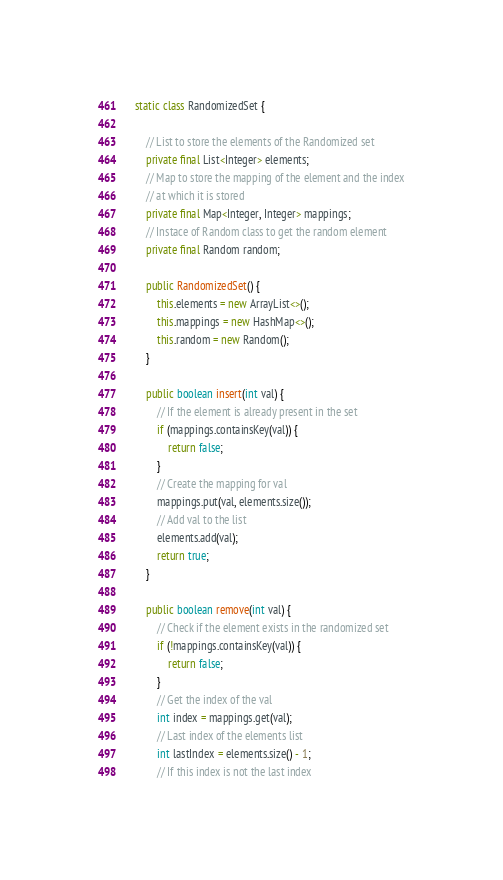Convert code to text. <code><loc_0><loc_0><loc_500><loc_500><_Java_>    static class RandomizedSet {

        // List to store the elements of the Randomized set
        private final List<Integer> elements;
        // Map to store the mapping of the element and the index
        // at which it is stored
        private final Map<Integer, Integer> mappings;
        // Instace of Random class to get the random element
        private final Random random;

        public RandomizedSet() {
            this.elements = new ArrayList<>();
            this.mappings = new HashMap<>();
            this.random = new Random();
        }

        public boolean insert(int val) {
            // If the element is already present in the set
            if (mappings.containsKey(val)) {
                return false;
            }
            // Create the mapping for val
            mappings.put(val, elements.size());
            // Add val to the list
            elements.add(val);
            return true;
        }

        public boolean remove(int val) {
            // Check if the element exists in the randomized set
            if (!mappings.containsKey(val)) {
                return false;
            }
            // Get the index of the val
            int index = mappings.get(val);
            // Last index of the elements list
            int lastIndex = elements.size() - 1;
            // If this index is not the last index</code> 